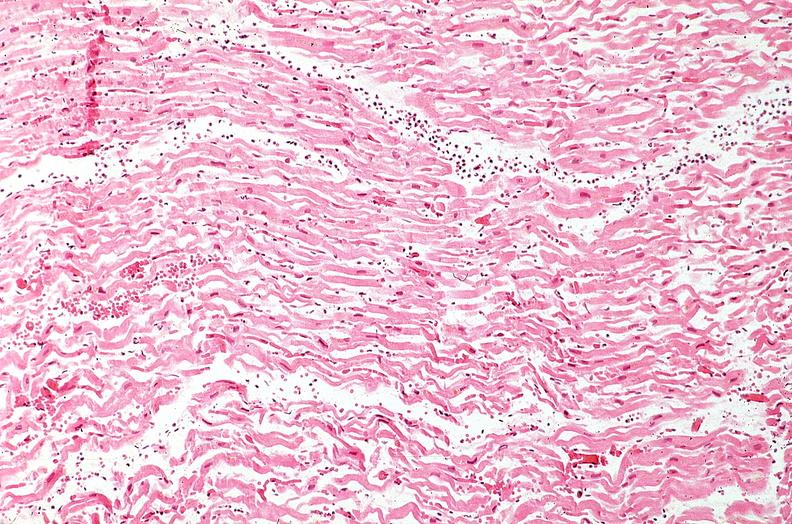what is present?
Answer the question using a single word or phrase. Cardiovascular 